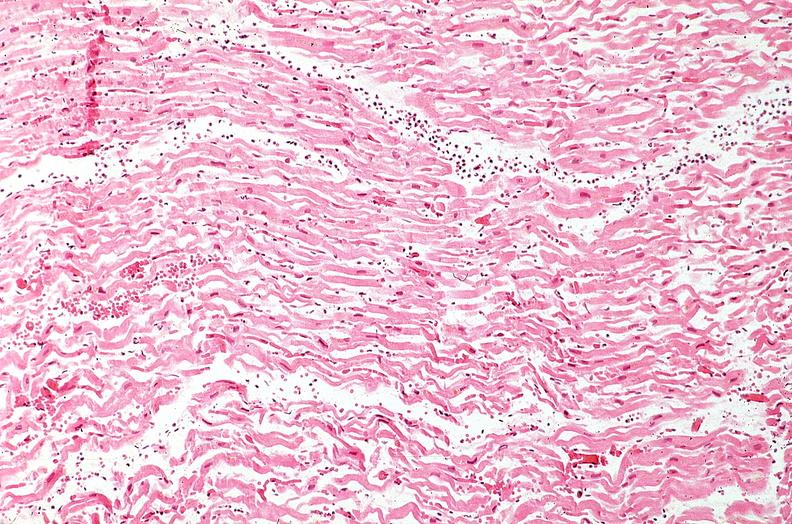what is present?
Answer the question using a single word or phrase. Cardiovascular 